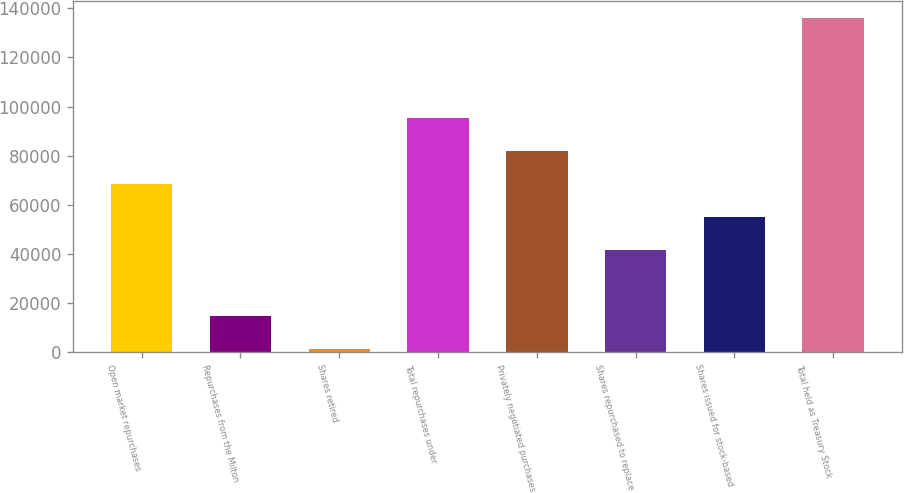Convert chart. <chart><loc_0><loc_0><loc_500><loc_500><bar_chart><fcel>Open market repurchases<fcel>Repurchases from the Milton<fcel>Shares retired<fcel>Total repurchases under<fcel>Privately negotiated purchases<fcel>Shares repurchased to replace<fcel>Shares issued for stock-based<fcel>Total held as Treasury Stock<nl><fcel>68351<fcel>14562<fcel>1056<fcel>95363<fcel>81857<fcel>41339<fcel>54845<fcel>136116<nl></chart> 